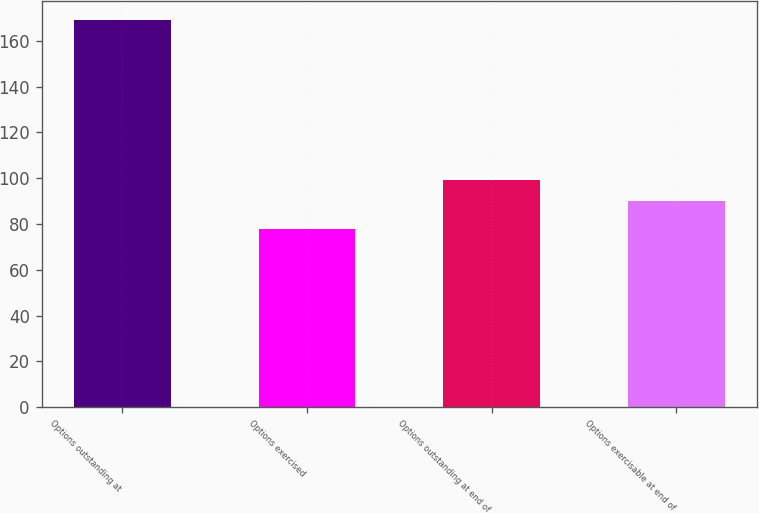Convert chart to OTSL. <chart><loc_0><loc_0><loc_500><loc_500><bar_chart><fcel>Options outstanding at<fcel>Options exercised<fcel>Options outstanding at end of<fcel>Options exercisable at end of<nl><fcel>169<fcel>78<fcel>99.1<fcel>90<nl></chart> 